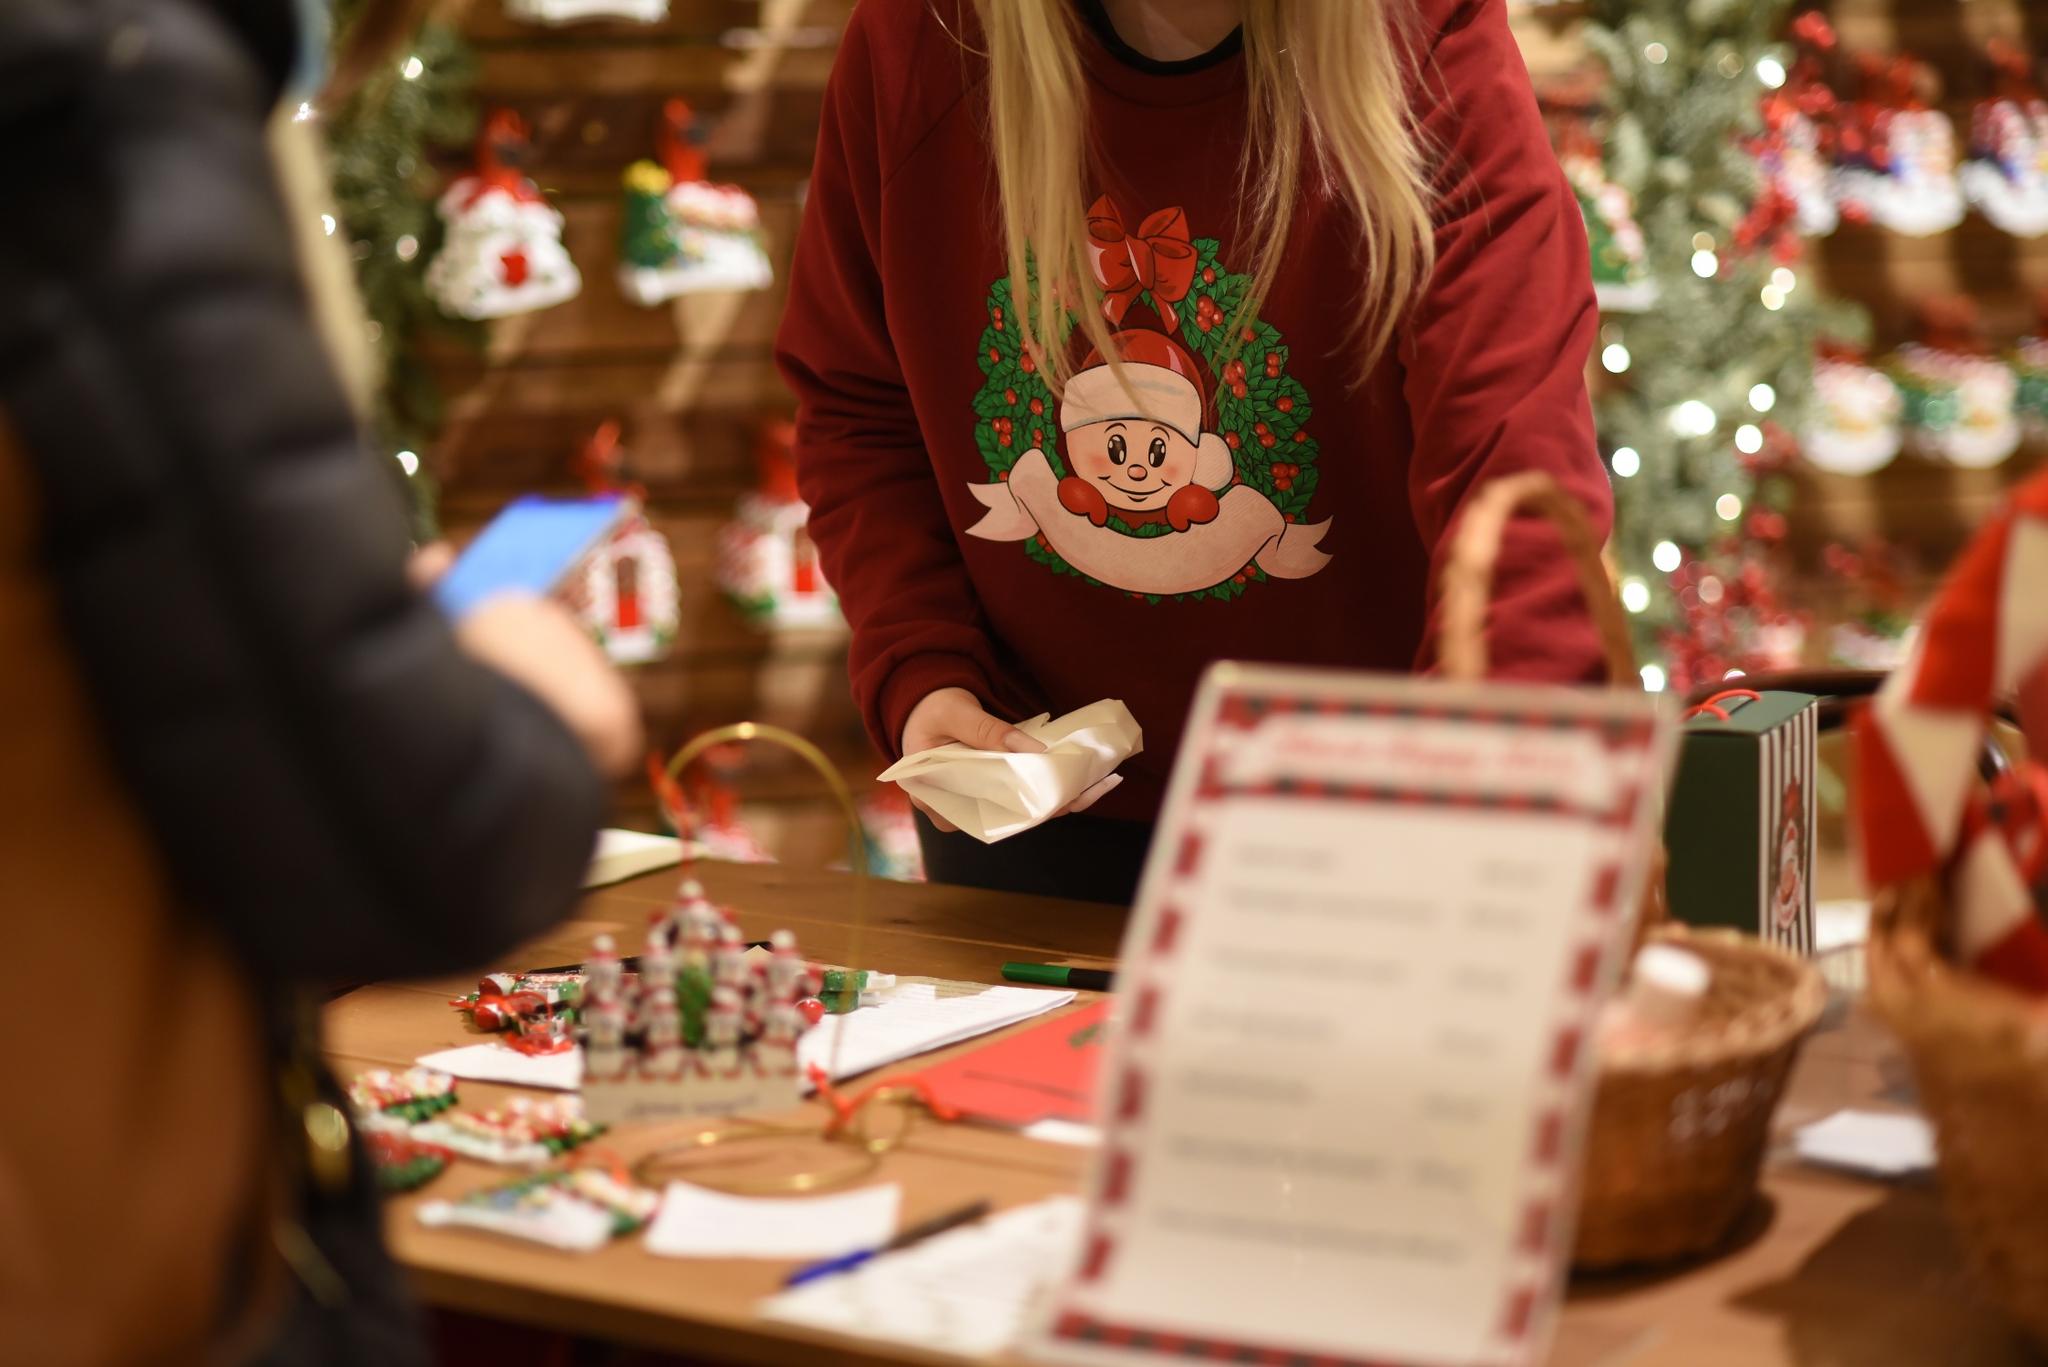Why do you think this person is wrapping gifts in this setting? It's likely that the person is wrapping gifts as part of their job, perhaps working in a Christmas-themed store or a gift wrapping service within a holiday market. Alternatively, they could be an enthusiastic individual who loves the holiday season and has set up a gift-wrapping station in their home or a community center to spread joy by preparing beautifully wrapped presents for friends, family, or charity. The festive surroundings add to the idea that this task is part of a larger celebration or event, aiming to share the magic and warmth of the Christmas season. 